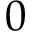Convert formula to latex. <formula><loc_0><loc_0><loc_500><loc_500>0</formula> 